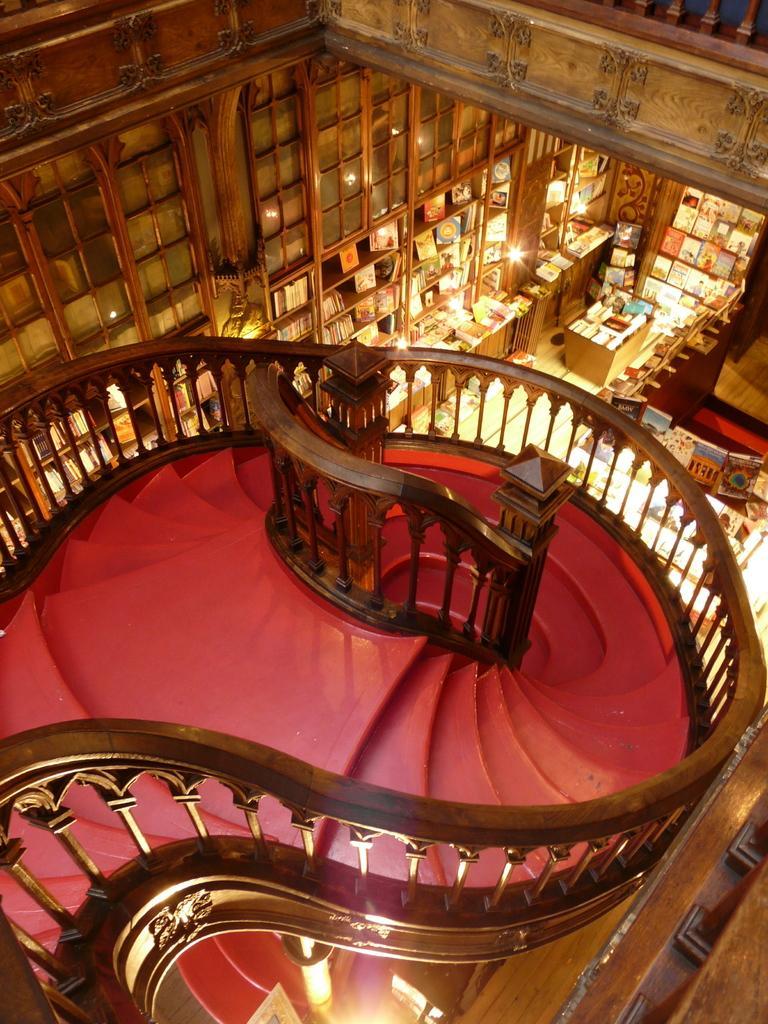Describe this image in one or two sentences. In this picture we can see the inside view of the library. At the bottom we can see the stairs and wooden railing. On the right we can see the books, lights, tables, wooden racks and doors. 